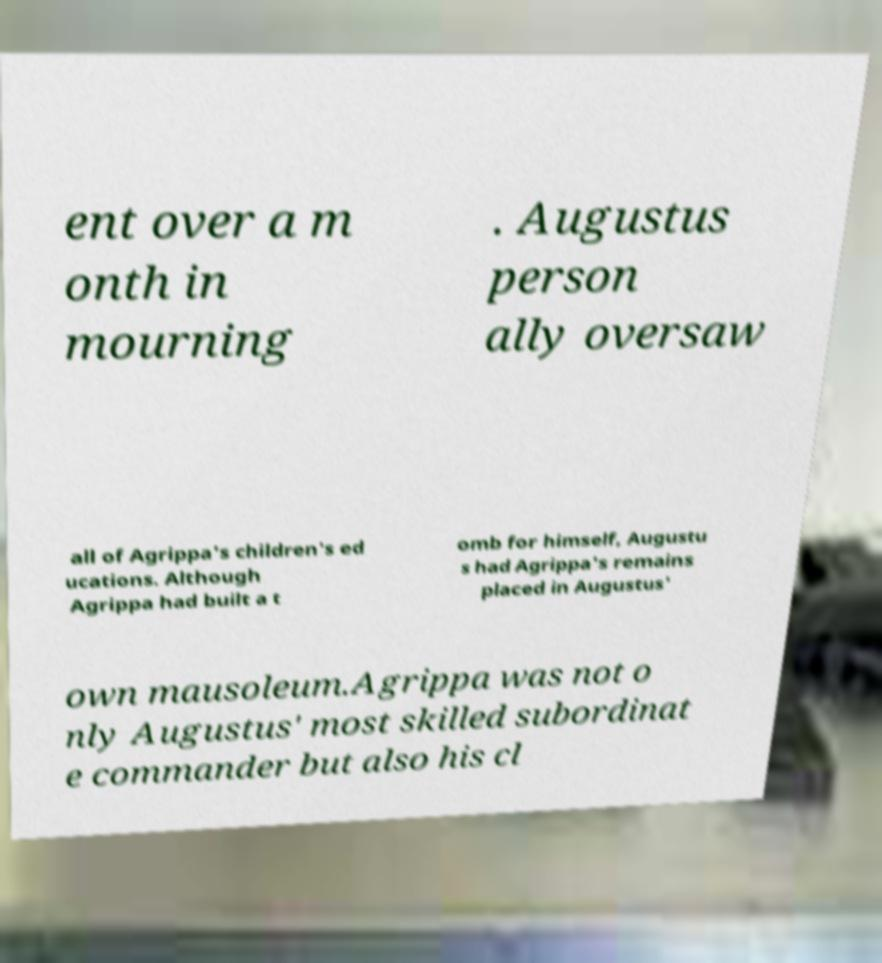For documentation purposes, I need the text within this image transcribed. Could you provide that? ent over a m onth in mourning . Augustus person ally oversaw all of Agrippa's children's ed ucations. Although Agrippa had built a t omb for himself, Augustu s had Agrippa's remains placed in Augustus' own mausoleum.Agrippa was not o nly Augustus' most skilled subordinat e commander but also his cl 